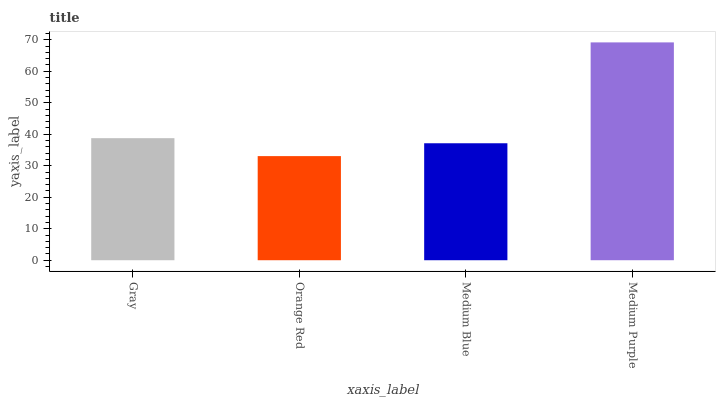Is Orange Red the minimum?
Answer yes or no. Yes. Is Medium Purple the maximum?
Answer yes or no. Yes. Is Medium Blue the minimum?
Answer yes or no. No. Is Medium Blue the maximum?
Answer yes or no. No. Is Medium Blue greater than Orange Red?
Answer yes or no. Yes. Is Orange Red less than Medium Blue?
Answer yes or no. Yes. Is Orange Red greater than Medium Blue?
Answer yes or no. No. Is Medium Blue less than Orange Red?
Answer yes or no. No. Is Gray the high median?
Answer yes or no. Yes. Is Medium Blue the low median?
Answer yes or no. Yes. Is Medium Purple the high median?
Answer yes or no. No. Is Gray the low median?
Answer yes or no. No. 